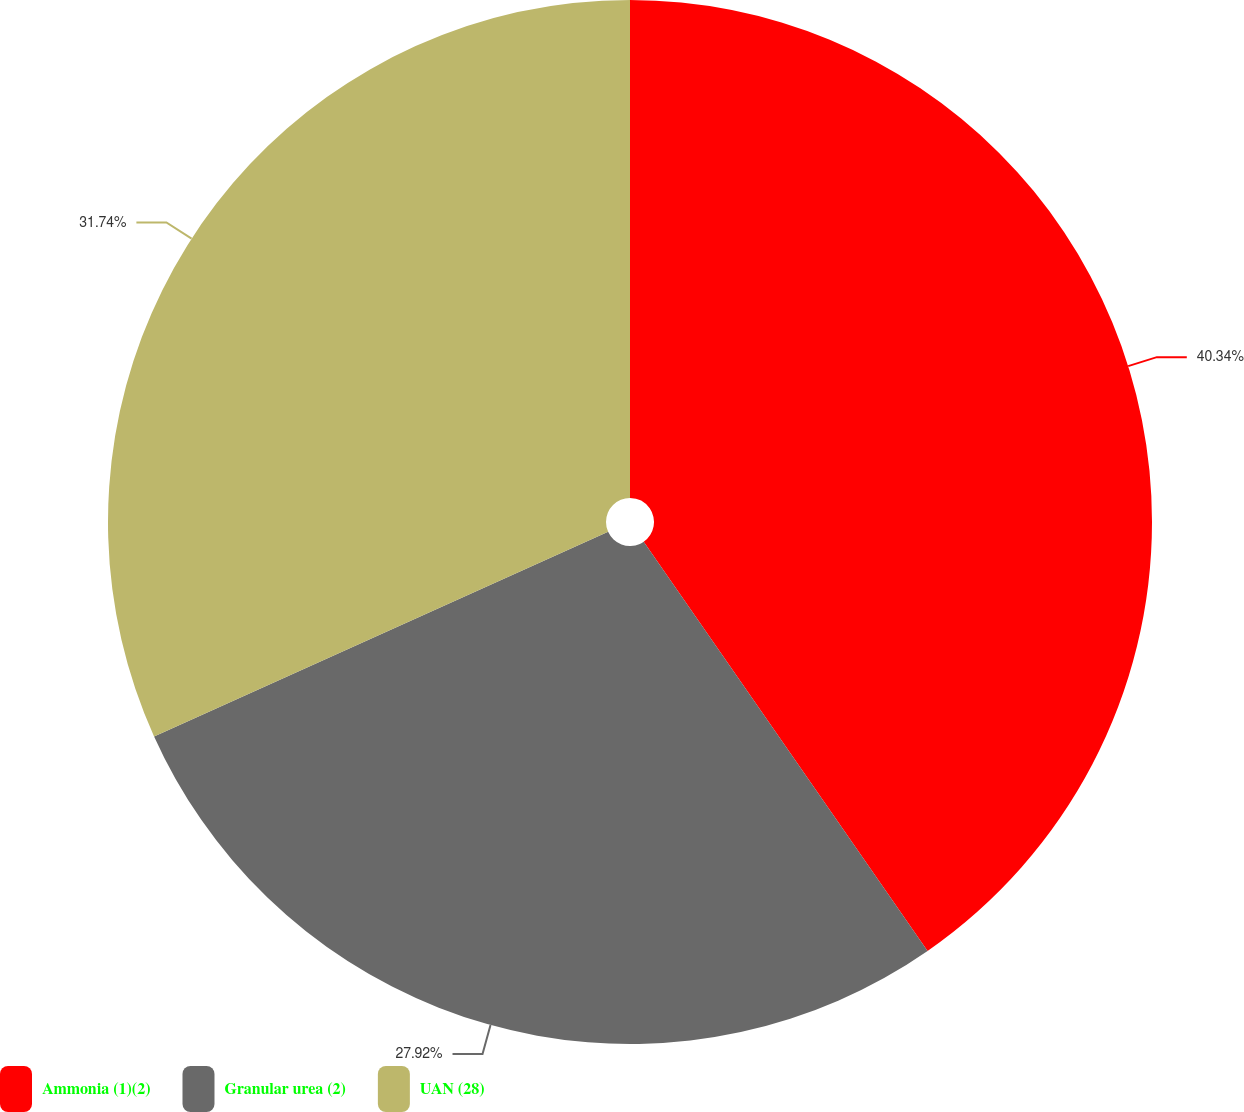<chart> <loc_0><loc_0><loc_500><loc_500><pie_chart><fcel>Ammonia (1)(2)<fcel>Granular urea (2)<fcel>UAN (28)<nl><fcel>40.35%<fcel>27.92%<fcel>31.74%<nl></chart> 